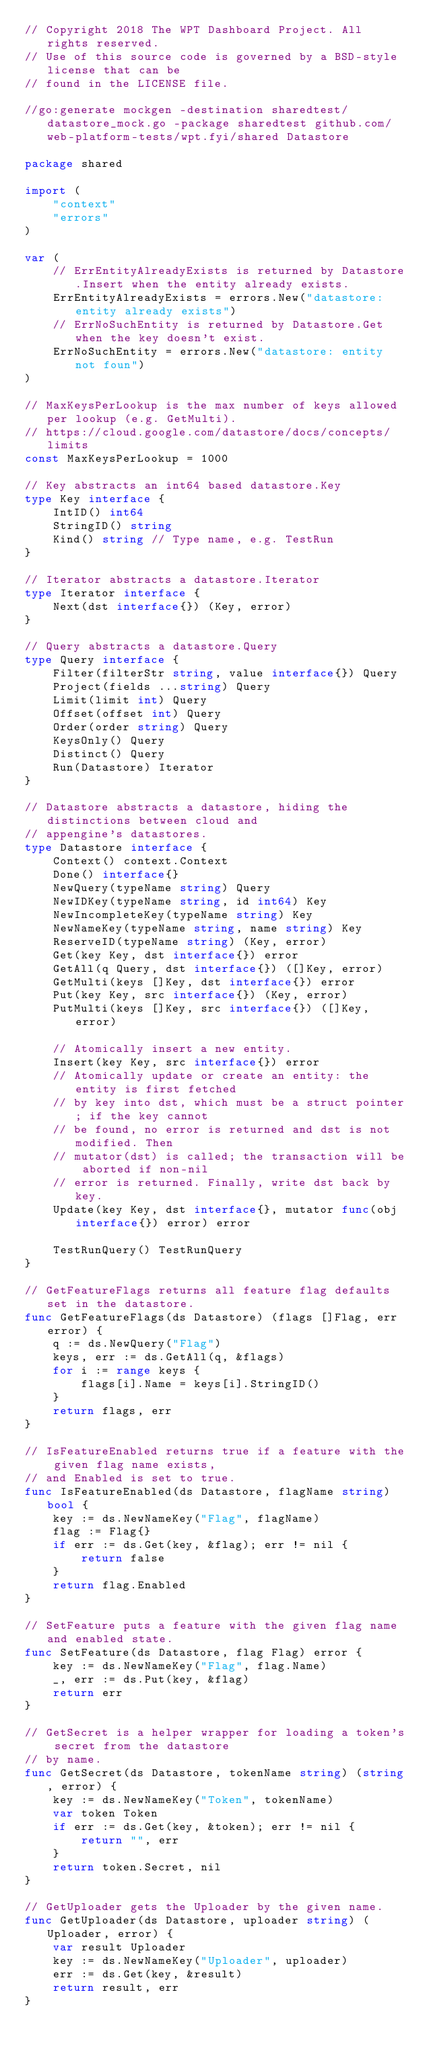Convert code to text. <code><loc_0><loc_0><loc_500><loc_500><_Go_>// Copyright 2018 The WPT Dashboard Project. All rights reserved.
// Use of this source code is governed by a BSD-style license that can be
// found in the LICENSE file.

//go:generate mockgen -destination sharedtest/datastore_mock.go -package sharedtest github.com/web-platform-tests/wpt.fyi/shared Datastore

package shared

import (
	"context"
	"errors"
)

var (
	// ErrEntityAlreadyExists is returned by Datastore.Insert when the entity already exists.
	ErrEntityAlreadyExists = errors.New("datastore: entity already exists")
	// ErrNoSuchEntity is returned by Datastore.Get when the key doesn't exist.
	ErrNoSuchEntity = errors.New("datastore: entity not foun")
)

// MaxKeysPerLookup is the max number of keys allowed per lookup (e.g. GetMulti).
// https://cloud.google.com/datastore/docs/concepts/limits
const MaxKeysPerLookup = 1000

// Key abstracts an int64 based datastore.Key
type Key interface {
	IntID() int64
	StringID() string
	Kind() string // Type name, e.g. TestRun
}

// Iterator abstracts a datastore.Iterator
type Iterator interface {
	Next(dst interface{}) (Key, error)
}

// Query abstracts a datastore.Query
type Query interface {
	Filter(filterStr string, value interface{}) Query
	Project(fields ...string) Query
	Limit(limit int) Query
	Offset(offset int) Query
	Order(order string) Query
	KeysOnly() Query
	Distinct() Query
	Run(Datastore) Iterator
}

// Datastore abstracts a datastore, hiding the distinctions between cloud and
// appengine's datastores.
type Datastore interface {
	Context() context.Context
	Done() interface{}
	NewQuery(typeName string) Query
	NewIDKey(typeName string, id int64) Key
	NewIncompleteKey(typeName string) Key
	NewNameKey(typeName string, name string) Key
	ReserveID(typeName string) (Key, error)
	Get(key Key, dst interface{}) error
	GetAll(q Query, dst interface{}) ([]Key, error)
	GetMulti(keys []Key, dst interface{}) error
	Put(key Key, src interface{}) (Key, error)
	PutMulti(keys []Key, src interface{}) ([]Key, error)

	// Atomically insert a new entity.
	Insert(key Key, src interface{}) error
	// Atomically update or create an entity: the entity is first fetched
	// by key into dst, which must be a struct pointer; if the key cannot
	// be found, no error is returned and dst is not modified. Then
	// mutator(dst) is called; the transaction will be aborted if non-nil
	// error is returned. Finally, write dst back by key.
	Update(key Key, dst interface{}, mutator func(obj interface{}) error) error

	TestRunQuery() TestRunQuery
}

// GetFeatureFlags returns all feature flag defaults set in the datastore.
func GetFeatureFlags(ds Datastore) (flags []Flag, err error) {
	q := ds.NewQuery("Flag")
	keys, err := ds.GetAll(q, &flags)
	for i := range keys {
		flags[i].Name = keys[i].StringID()
	}
	return flags, err
}

// IsFeatureEnabled returns true if a feature with the given flag name exists,
// and Enabled is set to true.
func IsFeatureEnabled(ds Datastore, flagName string) bool {
	key := ds.NewNameKey("Flag", flagName)
	flag := Flag{}
	if err := ds.Get(key, &flag); err != nil {
		return false
	}
	return flag.Enabled
}

// SetFeature puts a feature with the given flag name and enabled state.
func SetFeature(ds Datastore, flag Flag) error {
	key := ds.NewNameKey("Flag", flag.Name)
	_, err := ds.Put(key, &flag)
	return err
}

// GetSecret is a helper wrapper for loading a token's secret from the datastore
// by name.
func GetSecret(ds Datastore, tokenName string) (string, error) {
	key := ds.NewNameKey("Token", tokenName)
	var token Token
	if err := ds.Get(key, &token); err != nil {
		return "", err
	}
	return token.Secret, nil
}

// GetUploader gets the Uploader by the given name.
func GetUploader(ds Datastore, uploader string) (Uploader, error) {
	var result Uploader
	key := ds.NewNameKey("Uploader", uploader)
	err := ds.Get(key, &result)
	return result, err
}
</code> 